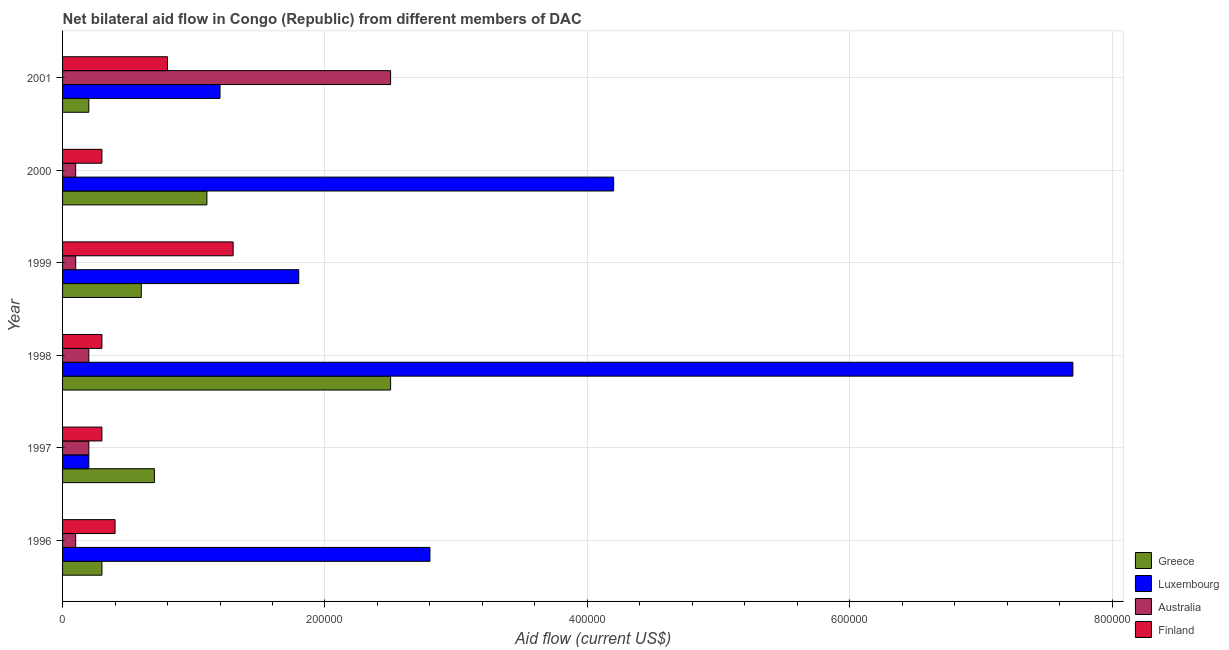Are the number of bars per tick equal to the number of legend labels?
Provide a succinct answer. Yes. How many bars are there on the 1st tick from the top?
Offer a terse response. 4. What is the amount of aid given by australia in 2000?
Offer a terse response. 10000. Across all years, what is the maximum amount of aid given by luxembourg?
Ensure brevity in your answer.  7.70e+05. Across all years, what is the minimum amount of aid given by australia?
Make the answer very short. 10000. What is the total amount of aid given by finland in the graph?
Provide a succinct answer. 3.40e+05. What is the difference between the amount of aid given by luxembourg in 1996 and that in 1998?
Offer a terse response. -4.90e+05. What is the difference between the amount of aid given by luxembourg in 2000 and the amount of aid given by greece in 1997?
Your answer should be very brief. 3.50e+05. What is the average amount of aid given by australia per year?
Your answer should be compact. 5.33e+04. In the year 2000, what is the difference between the amount of aid given by finland and amount of aid given by greece?
Provide a succinct answer. -8.00e+04. In how many years, is the amount of aid given by finland greater than 120000 US$?
Offer a terse response. 1. What is the ratio of the amount of aid given by australia in 1996 to that in 2000?
Your answer should be compact. 1. Is the amount of aid given by greece in 1999 less than that in 2000?
Make the answer very short. Yes. What is the difference between the highest and the lowest amount of aid given by finland?
Offer a terse response. 1.00e+05. In how many years, is the amount of aid given by australia greater than the average amount of aid given by australia taken over all years?
Give a very brief answer. 1. Is the sum of the amount of aid given by australia in 1999 and 2001 greater than the maximum amount of aid given by finland across all years?
Provide a short and direct response. Yes. Is it the case that in every year, the sum of the amount of aid given by australia and amount of aid given by luxembourg is greater than the sum of amount of aid given by greece and amount of aid given by finland?
Provide a succinct answer. No. What does the 4th bar from the top in 1996 represents?
Offer a very short reply. Greece. How many years are there in the graph?
Provide a short and direct response. 6. Does the graph contain any zero values?
Offer a terse response. No. Where does the legend appear in the graph?
Make the answer very short. Bottom right. How many legend labels are there?
Your answer should be very brief. 4. How are the legend labels stacked?
Offer a very short reply. Vertical. What is the title of the graph?
Provide a succinct answer. Net bilateral aid flow in Congo (Republic) from different members of DAC. Does "Primary" appear as one of the legend labels in the graph?
Provide a succinct answer. No. What is the label or title of the X-axis?
Your answer should be compact. Aid flow (current US$). What is the Aid flow (current US$) in Greece in 1996?
Provide a succinct answer. 3.00e+04. What is the Aid flow (current US$) in Luxembourg in 1996?
Your answer should be compact. 2.80e+05. What is the Aid flow (current US$) in Australia in 1996?
Keep it short and to the point. 10000. What is the Aid flow (current US$) of Greece in 1997?
Your answer should be very brief. 7.00e+04. What is the Aid flow (current US$) of Luxembourg in 1997?
Your response must be concise. 2.00e+04. What is the Aid flow (current US$) of Finland in 1997?
Your response must be concise. 3.00e+04. What is the Aid flow (current US$) in Greece in 1998?
Give a very brief answer. 2.50e+05. What is the Aid flow (current US$) of Luxembourg in 1998?
Give a very brief answer. 7.70e+05. What is the Aid flow (current US$) of Australia in 1998?
Keep it short and to the point. 2.00e+04. What is the Aid flow (current US$) in Finland in 1998?
Offer a very short reply. 3.00e+04. What is the Aid flow (current US$) of Luxembourg in 1999?
Offer a terse response. 1.80e+05. What is the Aid flow (current US$) of Australia in 1999?
Provide a succinct answer. 10000. What is the Aid flow (current US$) of Luxembourg in 2000?
Provide a succinct answer. 4.20e+05. What is the Aid flow (current US$) in Australia in 2000?
Your answer should be very brief. 10000. What is the Aid flow (current US$) of Finland in 2000?
Provide a short and direct response. 3.00e+04. What is the Aid flow (current US$) of Finland in 2001?
Provide a short and direct response. 8.00e+04. Across all years, what is the maximum Aid flow (current US$) in Luxembourg?
Make the answer very short. 7.70e+05. Across all years, what is the minimum Aid flow (current US$) in Greece?
Your answer should be very brief. 2.00e+04. What is the total Aid flow (current US$) of Greece in the graph?
Your answer should be very brief. 5.40e+05. What is the total Aid flow (current US$) in Luxembourg in the graph?
Your response must be concise. 1.79e+06. What is the total Aid flow (current US$) in Australia in the graph?
Offer a very short reply. 3.20e+05. What is the total Aid flow (current US$) in Finland in the graph?
Provide a succinct answer. 3.40e+05. What is the difference between the Aid flow (current US$) of Greece in 1996 and that in 1997?
Your response must be concise. -4.00e+04. What is the difference between the Aid flow (current US$) of Luxembourg in 1996 and that in 1997?
Ensure brevity in your answer.  2.60e+05. What is the difference between the Aid flow (current US$) in Australia in 1996 and that in 1997?
Offer a terse response. -10000. What is the difference between the Aid flow (current US$) in Greece in 1996 and that in 1998?
Your answer should be compact. -2.20e+05. What is the difference between the Aid flow (current US$) of Luxembourg in 1996 and that in 1998?
Give a very brief answer. -4.90e+05. What is the difference between the Aid flow (current US$) of Australia in 1996 and that in 1998?
Make the answer very short. -10000. What is the difference between the Aid flow (current US$) of Finland in 1996 and that in 1999?
Your answer should be compact. -9.00e+04. What is the difference between the Aid flow (current US$) of Australia in 1996 and that in 2000?
Your answer should be compact. 0. What is the difference between the Aid flow (current US$) in Finland in 1996 and that in 2000?
Your response must be concise. 10000. What is the difference between the Aid flow (current US$) in Australia in 1996 and that in 2001?
Ensure brevity in your answer.  -2.40e+05. What is the difference between the Aid flow (current US$) of Luxembourg in 1997 and that in 1998?
Your answer should be very brief. -7.50e+05. What is the difference between the Aid flow (current US$) of Australia in 1997 and that in 1998?
Ensure brevity in your answer.  0. What is the difference between the Aid flow (current US$) in Luxembourg in 1997 and that in 1999?
Ensure brevity in your answer.  -1.60e+05. What is the difference between the Aid flow (current US$) in Australia in 1997 and that in 1999?
Make the answer very short. 10000. What is the difference between the Aid flow (current US$) of Finland in 1997 and that in 1999?
Keep it short and to the point. -1.00e+05. What is the difference between the Aid flow (current US$) of Greece in 1997 and that in 2000?
Make the answer very short. -4.00e+04. What is the difference between the Aid flow (current US$) of Luxembourg in 1997 and that in 2000?
Offer a terse response. -4.00e+05. What is the difference between the Aid flow (current US$) of Greece in 1997 and that in 2001?
Give a very brief answer. 5.00e+04. What is the difference between the Aid flow (current US$) of Luxembourg in 1997 and that in 2001?
Provide a short and direct response. -1.00e+05. What is the difference between the Aid flow (current US$) of Australia in 1997 and that in 2001?
Make the answer very short. -2.30e+05. What is the difference between the Aid flow (current US$) in Greece in 1998 and that in 1999?
Make the answer very short. 1.90e+05. What is the difference between the Aid flow (current US$) of Luxembourg in 1998 and that in 1999?
Ensure brevity in your answer.  5.90e+05. What is the difference between the Aid flow (current US$) in Australia in 1998 and that in 2000?
Offer a very short reply. 10000. What is the difference between the Aid flow (current US$) in Finland in 1998 and that in 2000?
Offer a terse response. 0. What is the difference between the Aid flow (current US$) in Greece in 1998 and that in 2001?
Your answer should be compact. 2.30e+05. What is the difference between the Aid flow (current US$) of Luxembourg in 1998 and that in 2001?
Keep it short and to the point. 6.50e+05. What is the difference between the Aid flow (current US$) in Australia in 1998 and that in 2001?
Offer a terse response. -2.30e+05. What is the difference between the Aid flow (current US$) in Greece in 1999 and that in 2000?
Give a very brief answer. -5.00e+04. What is the difference between the Aid flow (current US$) of Luxembourg in 1999 and that in 2000?
Provide a short and direct response. -2.40e+05. What is the difference between the Aid flow (current US$) in Greece in 1999 and that in 2001?
Provide a short and direct response. 4.00e+04. What is the difference between the Aid flow (current US$) of Luxembourg in 1999 and that in 2001?
Give a very brief answer. 6.00e+04. What is the difference between the Aid flow (current US$) of Australia in 1999 and that in 2001?
Make the answer very short. -2.40e+05. What is the difference between the Aid flow (current US$) of Greece in 2000 and that in 2001?
Keep it short and to the point. 9.00e+04. What is the difference between the Aid flow (current US$) in Australia in 2000 and that in 2001?
Your response must be concise. -2.40e+05. What is the difference between the Aid flow (current US$) of Finland in 2000 and that in 2001?
Make the answer very short. -5.00e+04. What is the difference between the Aid flow (current US$) of Greece in 1996 and the Aid flow (current US$) of Luxembourg in 1997?
Offer a very short reply. 10000. What is the difference between the Aid flow (current US$) in Luxembourg in 1996 and the Aid flow (current US$) in Finland in 1997?
Your answer should be very brief. 2.50e+05. What is the difference between the Aid flow (current US$) in Greece in 1996 and the Aid flow (current US$) in Luxembourg in 1998?
Ensure brevity in your answer.  -7.40e+05. What is the difference between the Aid flow (current US$) of Luxembourg in 1996 and the Aid flow (current US$) of Australia in 1998?
Provide a succinct answer. 2.60e+05. What is the difference between the Aid flow (current US$) of Australia in 1996 and the Aid flow (current US$) of Finland in 1998?
Your response must be concise. -2.00e+04. What is the difference between the Aid flow (current US$) in Greece in 1996 and the Aid flow (current US$) in Australia in 1999?
Your answer should be compact. 2.00e+04. What is the difference between the Aid flow (current US$) of Luxembourg in 1996 and the Aid flow (current US$) of Australia in 1999?
Ensure brevity in your answer.  2.70e+05. What is the difference between the Aid flow (current US$) in Luxembourg in 1996 and the Aid flow (current US$) in Finland in 1999?
Your answer should be compact. 1.50e+05. What is the difference between the Aid flow (current US$) in Australia in 1996 and the Aid flow (current US$) in Finland in 1999?
Provide a succinct answer. -1.20e+05. What is the difference between the Aid flow (current US$) in Greece in 1996 and the Aid flow (current US$) in Luxembourg in 2000?
Provide a succinct answer. -3.90e+05. What is the difference between the Aid flow (current US$) of Luxembourg in 1996 and the Aid flow (current US$) of Finland in 2000?
Make the answer very short. 2.50e+05. What is the difference between the Aid flow (current US$) of Greece in 1996 and the Aid flow (current US$) of Luxembourg in 2001?
Ensure brevity in your answer.  -9.00e+04. What is the difference between the Aid flow (current US$) in Greece in 1996 and the Aid flow (current US$) in Australia in 2001?
Give a very brief answer. -2.20e+05. What is the difference between the Aid flow (current US$) of Luxembourg in 1996 and the Aid flow (current US$) of Australia in 2001?
Your answer should be compact. 3.00e+04. What is the difference between the Aid flow (current US$) of Australia in 1996 and the Aid flow (current US$) of Finland in 2001?
Keep it short and to the point. -7.00e+04. What is the difference between the Aid flow (current US$) in Greece in 1997 and the Aid flow (current US$) in Luxembourg in 1998?
Offer a very short reply. -7.00e+05. What is the difference between the Aid flow (current US$) in Greece in 1997 and the Aid flow (current US$) in Australia in 1998?
Provide a short and direct response. 5.00e+04. What is the difference between the Aid flow (current US$) in Luxembourg in 1997 and the Aid flow (current US$) in Finland in 1998?
Make the answer very short. -10000. What is the difference between the Aid flow (current US$) in Greece in 1997 and the Aid flow (current US$) in Luxembourg in 1999?
Provide a short and direct response. -1.10e+05. What is the difference between the Aid flow (current US$) in Greece in 1997 and the Aid flow (current US$) in Finland in 1999?
Your response must be concise. -6.00e+04. What is the difference between the Aid flow (current US$) of Luxembourg in 1997 and the Aid flow (current US$) of Finland in 1999?
Your answer should be compact. -1.10e+05. What is the difference between the Aid flow (current US$) of Australia in 1997 and the Aid flow (current US$) of Finland in 1999?
Offer a very short reply. -1.10e+05. What is the difference between the Aid flow (current US$) in Greece in 1997 and the Aid flow (current US$) in Luxembourg in 2000?
Offer a very short reply. -3.50e+05. What is the difference between the Aid flow (current US$) of Luxembourg in 1997 and the Aid flow (current US$) of Australia in 2000?
Your response must be concise. 10000. What is the difference between the Aid flow (current US$) in Greece in 1997 and the Aid flow (current US$) in Australia in 2001?
Offer a very short reply. -1.80e+05. What is the difference between the Aid flow (current US$) of Greece in 1997 and the Aid flow (current US$) of Finland in 2001?
Offer a very short reply. -10000. What is the difference between the Aid flow (current US$) of Luxembourg in 1997 and the Aid flow (current US$) of Finland in 2001?
Give a very brief answer. -6.00e+04. What is the difference between the Aid flow (current US$) in Australia in 1997 and the Aid flow (current US$) in Finland in 2001?
Give a very brief answer. -6.00e+04. What is the difference between the Aid flow (current US$) of Greece in 1998 and the Aid flow (current US$) of Luxembourg in 1999?
Offer a very short reply. 7.00e+04. What is the difference between the Aid flow (current US$) of Greece in 1998 and the Aid flow (current US$) of Australia in 1999?
Provide a succinct answer. 2.40e+05. What is the difference between the Aid flow (current US$) of Greece in 1998 and the Aid flow (current US$) of Finland in 1999?
Your answer should be very brief. 1.20e+05. What is the difference between the Aid flow (current US$) in Luxembourg in 1998 and the Aid flow (current US$) in Australia in 1999?
Keep it short and to the point. 7.60e+05. What is the difference between the Aid flow (current US$) in Luxembourg in 1998 and the Aid flow (current US$) in Finland in 1999?
Offer a very short reply. 6.40e+05. What is the difference between the Aid flow (current US$) in Greece in 1998 and the Aid flow (current US$) in Australia in 2000?
Provide a short and direct response. 2.40e+05. What is the difference between the Aid flow (current US$) in Luxembourg in 1998 and the Aid flow (current US$) in Australia in 2000?
Offer a terse response. 7.60e+05. What is the difference between the Aid flow (current US$) in Luxembourg in 1998 and the Aid flow (current US$) in Finland in 2000?
Your response must be concise. 7.40e+05. What is the difference between the Aid flow (current US$) of Australia in 1998 and the Aid flow (current US$) of Finland in 2000?
Make the answer very short. -10000. What is the difference between the Aid flow (current US$) of Greece in 1998 and the Aid flow (current US$) of Luxembourg in 2001?
Your response must be concise. 1.30e+05. What is the difference between the Aid flow (current US$) of Greece in 1998 and the Aid flow (current US$) of Australia in 2001?
Keep it short and to the point. 0. What is the difference between the Aid flow (current US$) of Greece in 1998 and the Aid flow (current US$) of Finland in 2001?
Your answer should be very brief. 1.70e+05. What is the difference between the Aid flow (current US$) of Luxembourg in 1998 and the Aid flow (current US$) of Australia in 2001?
Make the answer very short. 5.20e+05. What is the difference between the Aid flow (current US$) in Luxembourg in 1998 and the Aid flow (current US$) in Finland in 2001?
Make the answer very short. 6.90e+05. What is the difference between the Aid flow (current US$) of Greece in 1999 and the Aid flow (current US$) of Luxembourg in 2000?
Make the answer very short. -3.60e+05. What is the difference between the Aid flow (current US$) of Greece in 1999 and the Aid flow (current US$) of Australia in 2000?
Provide a succinct answer. 5.00e+04. What is the difference between the Aid flow (current US$) in Luxembourg in 1999 and the Aid flow (current US$) in Australia in 2000?
Give a very brief answer. 1.70e+05. What is the difference between the Aid flow (current US$) in Greece in 1999 and the Aid flow (current US$) in Australia in 2001?
Make the answer very short. -1.90e+05. What is the difference between the Aid flow (current US$) in Greece in 2000 and the Aid flow (current US$) in Finland in 2001?
Keep it short and to the point. 3.00e+04. What is the average Aid flow (current US$) of Greece per year?
Provide a succinct answer. 9.00e+04. What is the average Aid flow (current US$) in Luxembourg per year?
Keep it short and to the point. 2.98e+05. What is the average Aid flow (current US$) of Australia per year?
Offer a terse response. 5.33e+04. What is the average Aid flow (current US$) in Finland per year?
Ensure brevity in your answer.  5.67e+04. In the year 1996, what is the difference between the Aid flow (current US$) of Greece and Aid flow (current US$) of Luxembourg?
Offer a terse response. -2.50e+05. In the year 1996, what is the difference between the Aid flow (current US$) in Greece and Aid flow (current US$) in Australia?
Make the answer very short. 2.00e+04. In the year 1996, what is the difference between the Aid flow (current US$) in Luxembourg and Aid flow (current US$) in Finland?
Provide a succinct answer. 2.40e+05. In the year 1996, what is the difference between the Aid flow (current US$) of Australia and Aid flow (current US$) of Finland?
Ensure brevity in your answer.  -3.00e+04. In the year 1997, what is the difference between the Aid flow (current US$) of Greece and Aid flow (current US$) of Luxembourg?
Provide a short and direct response. 5.00e+04. In the year 1997, what is the difference between the Aid flow (current US$) in Greece and Aid flow (current US$) in Australia?
Provide a succinct answer. 5.00e+04. In the year 1997, what is the difference between the Aid flow (current US$) in Greece and Aid flow (current US$) in Finland?
Provide a succinct answer. 4.00e+04. In the year 1997, what is the difference between the Aid flow (current US$) of Luxembourg and Aid flow (current US$) of Australia?
Provide a short and direct response. 0. In the year 1997, what is the difference between the Aid flow (current US$) in Luxembourg and Aid flow (current US$) in Finland?
Ensure brevity in your answer.  -10000. In the year 1998, what is the difference between the Aid flow (current US$) in Greece and Aid flow (current US$) in Luxembourg?
Keep it short and to the point. -5.20e+05. In the year 1998, what is the difference between the Aid flow (current US$) in Greece and Aid flow (current US$) in Australia?
Ensure brevity in your answer.  2.30e+05. In the year 1998, what is the difference between the Aid flow (current US$) of Luxembourg and Aid flow (current US$) of Australia?
Ensure brevity in your answer.  7.50e+05. In the year 1998, what is the difference between the Aid flow (current US$) of Luxembourg and Aid flow (current US$) of Finland?
Keep it short and to the point. 7.40e+05. In the year 1998, what is the difference between the Aid flow (current US$) of Australia and Aid flow (current US$) of Finland?
Your answer should be compact. -10000. In the year 1999, what is the difference between the Aid flow (current US$) of Greece and Aid flow (current US$) of Luxembourg?
Your answer should be very brief. -1.20e+05. In the year 1999, what is the difference between the Aid flow (current US$) in Luxembourg and Aid flow (current US$) in Australia?
Provide a succinct answer. 1.70e+05. In the year 1999, what is the difference between the Aid flow (current US$) in Luxembourg and Aid flow (current US$) in Finland?
Offer a very short reply. 5.00e+04. In the year 2000, what is the difference between the Aid flow (current US$) in Greece and Aid flow (current US$) in Luxembourg?
Make the answer very short. -3.10e+05. In the year 2000, what is the difference between the Aid flow (current US$) of Greece and Aid flow (current US$) of Australia?
Keep it short and to the point. 1.00e+05. In the year 2000, what is the difference between the Aid flow (current US$) in Greece and Aid flow (current US$) in Finland?
Your answer should be very brief. 8.00e+04. In the year 2000, what is the difference between the Aid flow (current US$) in Australia and Aid flow (current US$) in Finland?
Provide a short and direct response. -2.00e+04. In the year 2001, what is the difference between the Aid flow (current US$) of Greece and Aid flow (current US$) of Finland?
Make the answer very short. -6.00e+04. In the year 2001, what is the difference between the Aid flow (current US$) in Luxembourg and Aid flow (current US$) in Finland?
Your answer should be very brief. 4.00e+04. In the year 2001, what is the difference between the Aid flow (current US$) in Australia and Aid flow (current US$) in Finland?
Provide a short and direct response. 1.70e+05. What is the ratio of the Aid flow (current US$) of Greece in 1996 to that in 1997?
Keep it short and to the point. 0.43. What is the ratio of the Aid flow (current US$) of Luxembourg in 1996 to that in 1997?
Offer a terse response. 14. What is the ratio of the Aid flow (current US$) in Australia in 1996 to that in 1997?
Keep it short and to the point. 0.5. What is the ratio of the Aid flow (current US$) in Greece in 1996 to that in 1998?
Your response must be concise. 0.12. What is the ratio of the Aid flow (current US$) in Luxembourg in 1996 to that in 1998?
Give a very brief answer. 0.36. What is the ratio of the Aid flow (current US$) in Australia in 1996 to that in 1998?
Give a very brief answer. 0.5. What is the ratio of the Aid flow (current US$) of Greece in 1996 to that in 1999?
Provide a succinct answer. 0.5. What is the ratio of the Aid flow (current US$) of Luxembourg in 1996 to that in 1999?
Give a very brief answer. 1.56. What is the ratio of the Aid flow (current US$) of Australia in 1996 to that in 1999?
Offer a very short reply. 1. What is the ratio of the Aid flow (current US$) in Finland in 1996 to that in 1999?
Your answer should be compact. 0.31. What is the ratio of the Aid flow (current US$) in Greece in 1996 to that in 2000?
Offer a terse response. 0.27. What is the ratio of the Aid flow (current US$) of Luxembourg in 1996 to that in 2000?
Give a very brief answer. 0.67. What is the ratio of the Aid flow (current US$) of Australia in 1996 to that in 2000?
Your answer should be very brief. 1. What is the ratio of the Aid flow (current US$) in Finland in 1996 to that in 2000?
Ensure brevity in your answer.  1.33. What is the ratio of the Aid flow (current US$) of Greece in 1996 to that in 2001?
Provide a short and direct response. 1.5. What is the ratio of the Aid flow (current US$) in Luxembourg in 1996 to that in 2001?
Your answer should be very brief. 2.33. What is the ratio of the Aid flow (current US$) in Australia in 1996 to that in 2001?
Give a very brief answer. 0.04. What is the ratio of the Aid flow (current US$) in Finland in 1996 to that in 2001?
Your answer should be compact. 0.5. What is the ratio of the Aid flow (current US$) in Greece in 1997 to that in 1998?
Your response must be concise. 0.28. What is the ratio of the Aid flow (current US$) in Luxembourg in 1997 to that in 1998?
Make the answer very short. 0.03. What is the ratio of the Aid flow (current US$) in Greece in 1997 to that in 1999?
Give a very brief answer. 1.17. What is the ratio of the Aid flow (current US$) of Finland in 1997 to that in 1999?
Keep it short and to the point. 0.23. What is the ratio of the Aid flow (current US$) in Greece in 1997 to that in 2000?
Give a very brief answer. 0.64. What is the ratio of the Aid flow (current US$) in Luxembourg in 1997 to that in 2000?
Provide a succinct answer. 0.05. What is the ratio of the Aid flow (current US$) of Finland in 1997 to that in 2000?
Your response must be concise. 1. What is the ratio of the Aid flow (current US$) in Australia in 1997 to that in 2001?
Ensure brevity in your answer.  0.08. What is the ratio of the Aid flow (current US$) of Greece in 1998 to that in 1999?
Offer a terse response. 4.17. What is the ratio of the Aid flow (current US$) of Luxembourg in 1998 to that in 1999?
Keep it short and to the point. 4.28. What is the ratio of the Aid flow (current US$) in Australia in 1998 to that in 1999?
Provide a short and direct response. 2. What is the ratio of the Aid flow (current US$) of Finland in 1998 to that in 1999?
Your answer should be very brief. 0.23. What is the ratio of the Aid flow (current US$) of Greece in 1998 to that in 2000?
Offer a very short reply. 2.27. What is the ratio of the Aid flow (current US$) in Luxembourg in 1998 to that in 2000?
Give a very brief answer. 1.83. What is the ratio of the Aid flow (current US$) in Greece in 1998 to that in 2001?
Your response must be concise. 12.5. What is the ratio of the Aid flow (current US$) of Luxembourg in 1998 to that in 2001?
Offer a terse response. 6.42. What is the ratio of the Aid flow (current US$) in Australia in 1998 to that in 2001?
Your answer should be compact. 0.08. What is the ratio of the Aid flow (current US$) in Finland in 1998 to that in 2001?
Offer a very short reply. 0.38. What is the ratio of the Aid flow (current US$) of Greece in 1999 to that in 2000?
Provide a succinct answer. 0.55. What is the ratio of the Aid flow (current US$) of Luxembourg in 1999 to that in 2000?
Your response must be concise. 0.43. What is the ratio of the Aid flow (current US$) of Australia in 1999 to that in 2000?
Keep it short and to the point. 1. What is the ratio of the Aid flow (current US$) of Finland in 1999 to that in 2000?
Your answer should be very brief. 4.33. What is the ratio of the Aid flow (current US$) of Luxembourg in 1999 to that in 2001?
Ensure brevity in your answer.  1.5. What is the ratio of the Aid flow (current US$) of Australia in 1999 to that in 2001?
Make the answer very short. 0.04. What is the ratio of the Aid flow (current US$) in Finland in 1999 to that in 2001?
Give a very brief answer. 1.62. What is the ratio of the Aid flow (current US$) in Luxembourg in 2000 to that in 2001?
Your response must be concise. 3.5. What is the difference between the highest and the second highest Aid flow (current US$) in Australia?
Your answer should be compact. 2.30e+05. What is the difference between the highest and the lowest Aid flow (current US$) in Luxembourg?
Your answer should be very brief. 7.50e+05. 